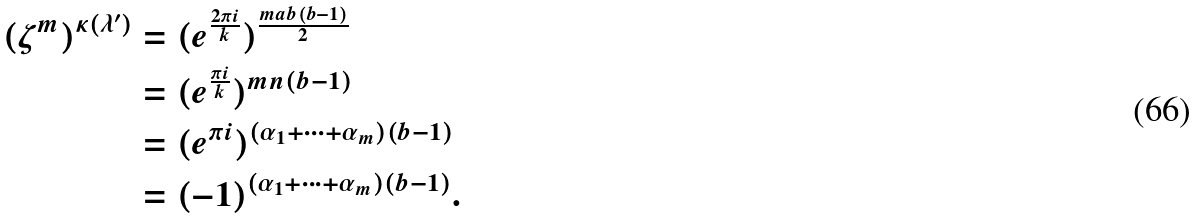Convert formula to latex. <formula><loc_0><loc_0><loc_500><loc_500>( \zeta ^ { m } ) ^ { \kappa ( \lambda ^ { \prime } ) } & = ( e ^ { \frac { 2 \pi i } { k } } ) ^ { \frac { m a b ( b - 1 ) } { 2 } } \\ & = ( e ^ { \frac { \pi i } { k } } ) ^ { m n ( b - 1 ) } \\ & = ( e ^ { \pi i } ) ^ { ( \alpha _ { 1 } + \dots + \alpha _ { m } ) ( b - 1 ) } \\ & = ( - 1 ) ^ { ( \alpha _ { 1 } + \dots + \alpha _ { m } ) ( b - 1 ) } . \\</formula> 